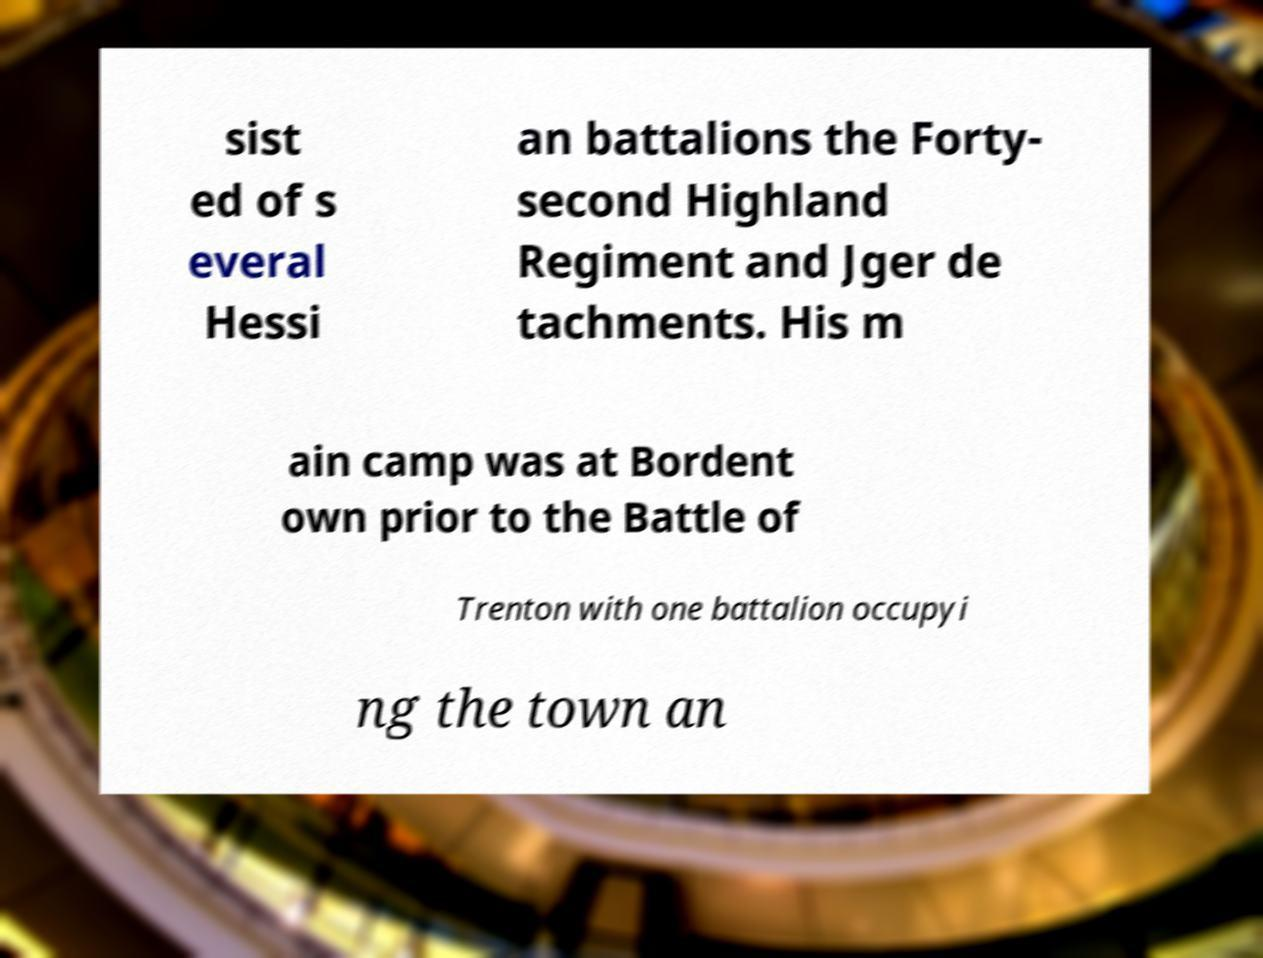Could you extract and type out the text from this image? sist ed of s everal Hessi an battalions the Forty- second Highland Regiment and Jger de tachments. His m ain camp was at Bordent own prior to the Battle of Trenton with one battalion occupyi ng the town an 